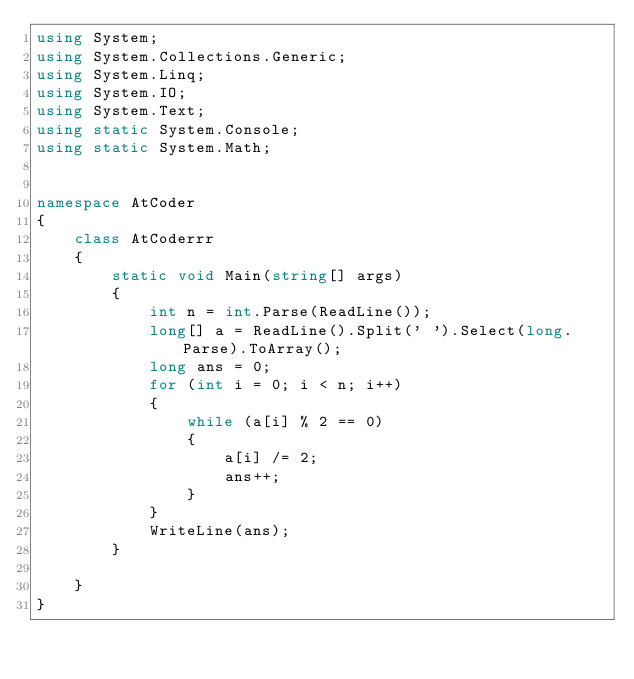Convert code to text. <code><loc_0><loc_0><loc_500><loc_500><_C#_>using System;
using System.Collections.Generic;
using System.Linq;
using System.IO;
using System.Text;
using static System.Console;
using static System.Math;


namespace AtCoder
{
    class AtCoderrr
    {
        static void Main(string[] args)
        {
            int n = int.Parse(ReadLine());
            long[] a = ReadLine().Split(' ').Select(long.Parse).ToArray();
            long ans = 0;
            for (int i = 0; i < n; i++)
            {
                while (a[i] % 2 == 0)
                {
                    a[i] /= 2;
                    ans++;
                }
            }
            WriteLine(ans);
        }
        
    }
}
</code> 